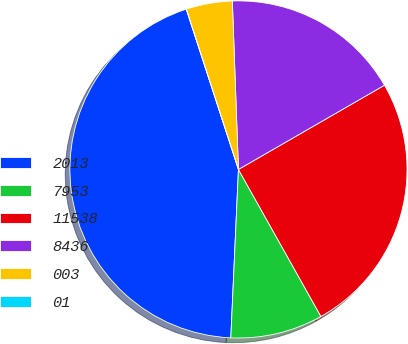<chart> <loc_0><loc_0><loc_500><loc_500><pie_chart><fcel>2013<fcel>7953<fcel>11538<fcel>8436<fcel>003<fcel>01<nl><fcel>44.27%<fcel>8.86%<fcel>25.19%<fcel>17.25%<fcel>4.43%<fcel>0.0%<nl></chart> 